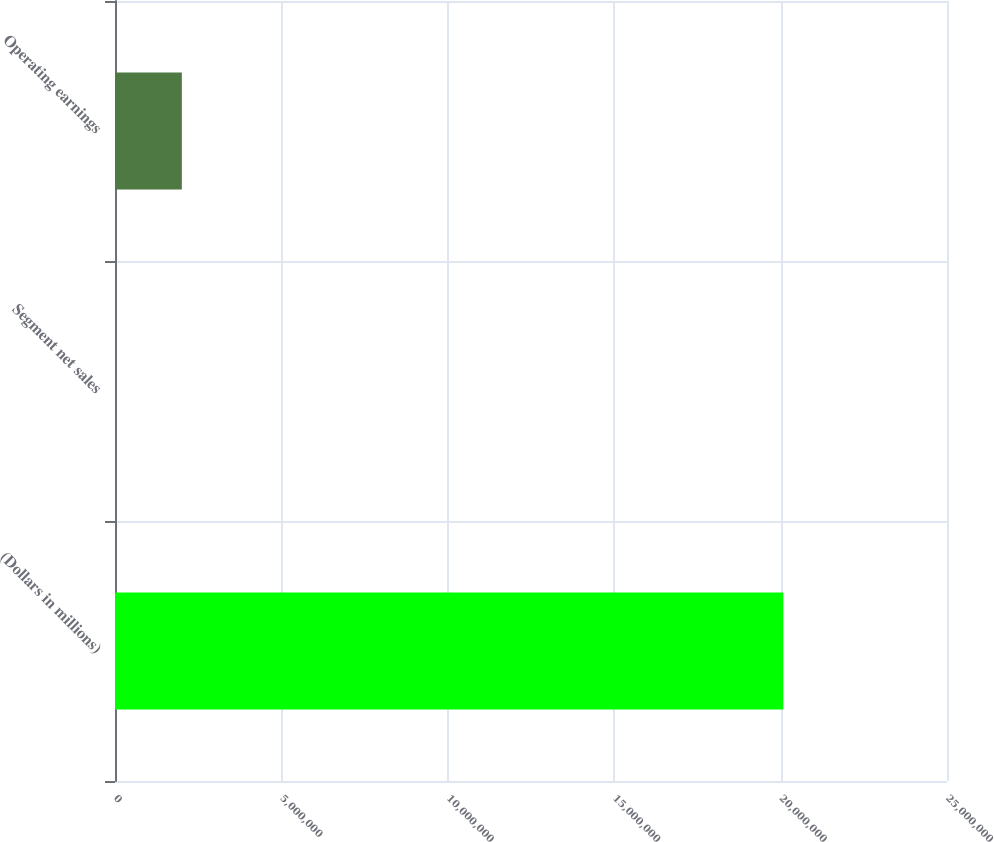Convert chart. <chart><loc_0><loc_0><loc_500><loc_500><bar_chart><fcel>(Dollars in millions)<fcel>Segment net sales<fcel>Operating earnings<nl><fcel>2.0082e+07<fcel>1<fcel>2.0082e+06<nl></chart> 